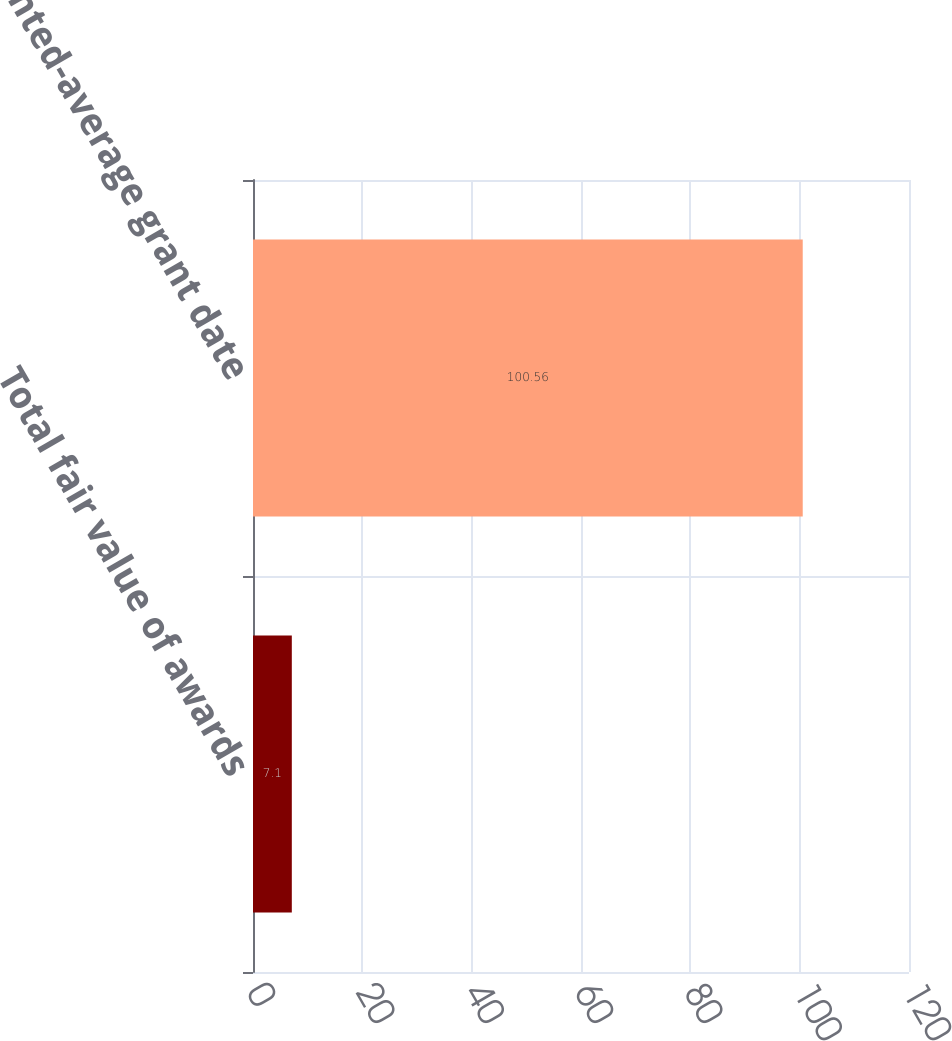<chart> <loc_0><loc_0><loc_500><loc_500><bar_chart><fcel>Total fair value of awards<fcel>Weighted-average grant date<nl><fcel>7.1<fcel>100.56<nl></chart> 